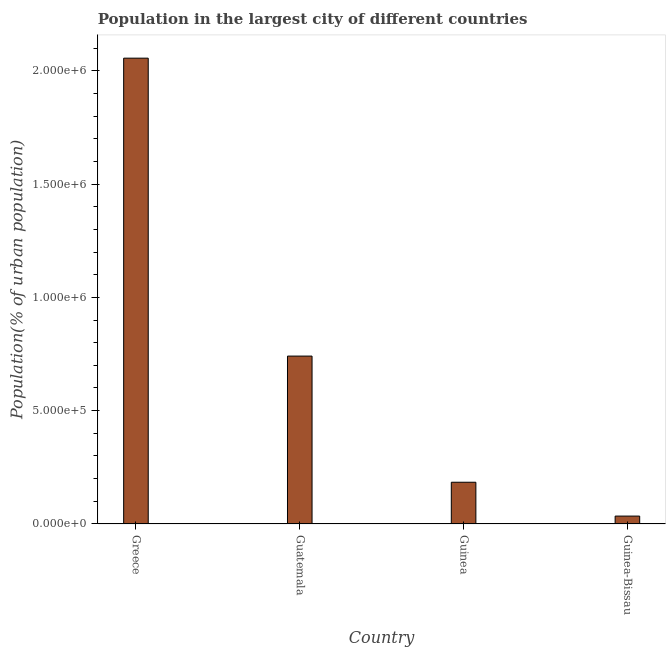Does the graph contain any zero values?
Your answer should be very brief. No. Does the graph contain grids?
Make the answer very short. No. What is the title of the graph?
Provide a short and direct response. Population in the largest city of different countries. What is the label or title of the X-axis?
Keep it short and to the point. Country. What is the label or title of the Y-axis?
Your response must be concise. Population(% of urban population). What is the population in largest city in Greece?
Provide a succinct answer. 2.06e+06. Across all countries, what is the maximum population in largest city?
Make the answer very short. 2.06e+06. Across all countries, what is the minimum population in largest city?
Provide a short and direct response. 3.48e+04. In which country was the population in largest city maximum?
Your response must be concise. Greece. In which country was the population in largest city minimum?
Ensure brevity in your answer.  Guinea-Bissau. What is the sum of the population in largest city?
Provide a short and direct response. 3.02e+06. What is the difference between the population in largest city in Guinea and Guinea-Bissau?
Your response must be concise. 1.49e+05. What is the average population in largest city per country?
Your answer should be very brief. 7.54e+05. What is the median population in largest city?
Make the answer very short. 4.63e+05. What is the ratio of the population in largest city in Guatemala to that in Guinea-Bissau?
Your response must be concise. 21.28. What is the difference between the highest and the second highest population in largest city?
Give a very brief answer. 1.31e+06. What is the difference between the highest and the lowest population in largest city?
Provide a succinct answer. 2.02e+06. Are all the bars in the graph horizontal?
Make the answer very short. No. How many countries are there in the graph?
Your response must be concise. 4. What is the Population(% of urban population) in Greece?
Give a very brief answer. 2.06e+06. What is the Population(% of urban population) in Guatemala?
Your response must be concise. 7.41e+05. What is the Population(% of urban population) of Guinea?
Make the answer very short. 1.84e+05. What is the Population(% of urban population) in Guinea-Bissau?
Offer a terse response. 3.48e+04. What is the difference between the Population(% of urban population) in Greece and Guatemala?
Offer a very short reply. 1.31e+06. What is the difference between the Population(% of urban population) in Greece and Guinea?
Your response must be concise. 1.87e+06. What is the difference between the Population(% of urban population) in Greece and Guinea-Bissau?
Offer a terse response. 2.02e+06. What is the difference between the Population(% of urban population) in Guatemala and Guinea?
Offer a terse response. 5.57e+05. What is the difference between the Population(% of urban population) in Guatemala and Guinea-Bissau?
Offer a very short reply. 7.06e+05. What is the difference between the Population(% of urban population) in Guinea and Guinea-Bissau?
Offer a very short reply. 1.49e+05. What is the ratio of the Population(% of urban population) in Greece to that in Guatemala?
Provide a short and direct response. 2.77. What is the ratio of the Population(% of urban population) in Greece to that in Guinea?
Your response must be concise. 11.16. What is the ratio of the Population(% of urban population) in Greece to that in Guinea-Bissau?
Offer a very short reply. 59.05. What is the ratio of the Population(% of urban population) in Guatemala to that in Guinea?
Offer a very short reply. 4.02. What is the ratio of the Population(% of urban population) in Guatemala to that in Guinea-Bissau?
Offer a terse response. 21.28. What is the ratio of the Population(% of urban population) in Guinea to that in Guinea-Bissau?
Provide a succinct answer. 5.29. 